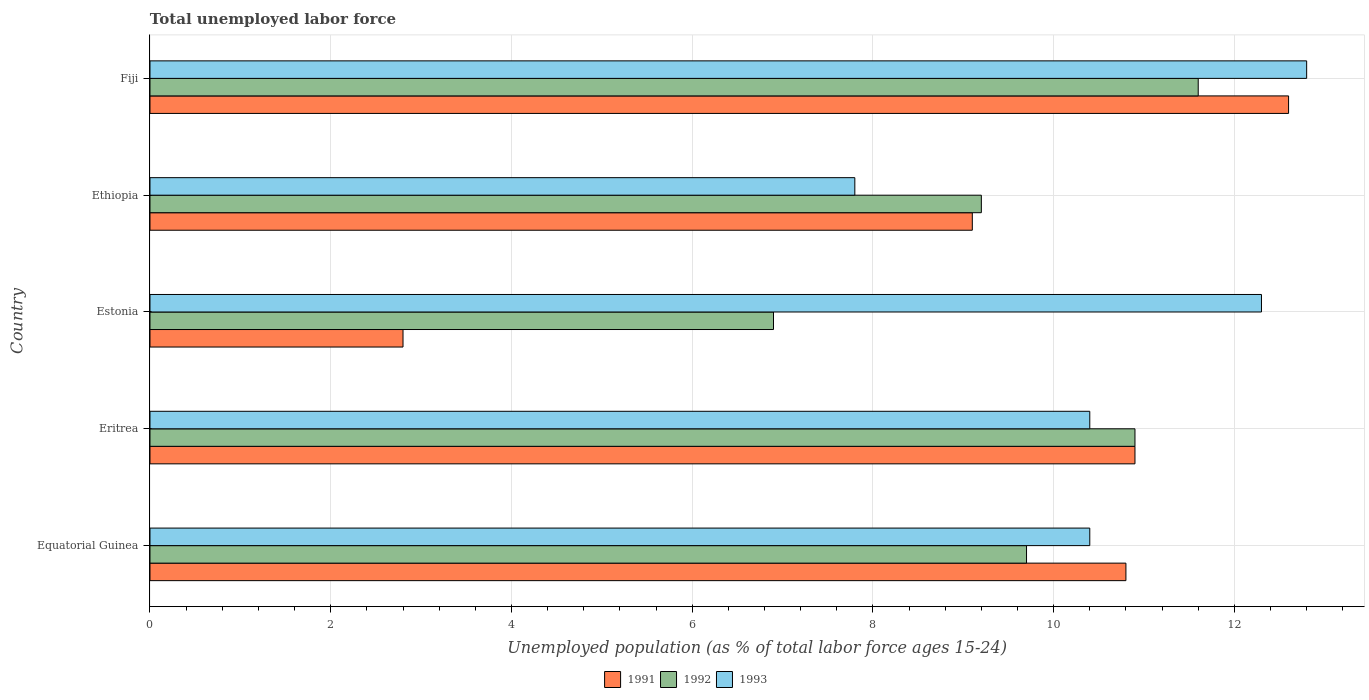How many different coloured bars are there?
Ensure brevity in your answer.  3. How many groups of bars are there?
Your answer should be compact. 5. Are the number of bars on each tick of the Y-axis equal?
Make the answer very short. Yes. How many bars are there on the 5th tick from the top?
Provide a succinct answer. 3. What is the label of the 5th group of bars from the top?
Give a very brief answer. Equatorial Guinea. In how many cases, is the number of bars for a given country not equal to the number of legend labels?
Keep it short and to the point. 0. What is the percentage of unemployed population in in 1992 in Eritrea?
Provide a short and direct response. 10.9. Across all countries, what is the maximum percentage of unemployed population in in 1993?
Your answer should be very brief. 12.8. Across all countries, what is the minimum percentage of unemployed population in in 1993?
Give a very brief answer. 7.8. In which country was the percentage of unemployed population in in 1992 maximum?
Ensure brevity in your answer.  Fiji. In which country was the percentage of unemployed population in in 1992 minimum?
Your response must be concise. Estonia. What is the total percentage of unemployed population in in 1992 in the graph?
Offer a very short reply. 48.3. What is the difference between the percentage of unemployed population in in 1991 in Eritrea and that in Estonia?
Make the answer very short. 8.1. What is the difference between the percentage of unemployed population in in 1991 in Equatorial Guinea and the percentage of unemployed population in in 1992 in Estonia?
Offer a terse response. 3.9. What is the average percentage of unemployed population in in 1991 per country?
Offer a very short reply. 9.24. What is the difference between the percentage of unemployed population in in 1991 and percentage of unemployed population in in 1993 in Estonia?
Your answer should be very brief. -9.5. What is the ratio of the percentage of unemployed population in in 1992 in Ethiopia to that in Fiji?
Your response must be concise. 0.79. What is the difference between the highest and the second highest percentage of unemployed population in in 1992?
Your answer should be very brief. 0.7. What is the difference between the highest and the lowest percentage of unemployed population in in 1991?
Ensure brevity in your answer.  9.8. In how many countries, is the percentage of unemployed population in in 1991 greater than the average percentage of unemployed population in in 1991 taken over all countries?
Keep it short and to the point. 3. Is the sum of the percentage of unemployed population in in 1993 in Equatorial Guinea and Ethiopia greater than the maximum percentage of unemployed population in in 1991 across all countries?
Provide a short and direct response. Yes. How many bars are there?
Ensure brevity in your answer.  15. What is the difference between two consecutive major ticks on the X-axis?
Make the answer very short. 2. Are the values on the major ticks of X-axis written in scientific E-notation?
Make the answer very short. No. Does the graph contain any zero values?
Your answer should be compact. No. Does the graph contain grids?
Offer a very short reply. Yes. How many legend labels are there?
Your answer should be very brief. 3. What is the title of the graph?
Make the answer very short. Total unemployed labor force. Does "1964" appear as one of the legend labels in the graph?
Your answer should be very brief. No. What is the label or title of the X-axis?
Offer a terse response. Unemployed population (as % of total labor force ages 15-24). What is the label or title of the Y-axis?
Your answer should be very brief. Country. What is the Unemployed population (as % of total labor force ages 15-24) of 1991 in Equatorial Guinea?
Make the answer very short. 10.8. What is the Unemployed population (as % of total labor force ages 15-24) of 1992 in Equatorial Guinea?
Your answer should be compact. 9.7. What is the Unemployed population (as % of total labor force ages 15-24) in 1993 in Equatorial Guinea?
Offer a terse response. 10.4. What is the Unemployed population (as % of total labor force ages 15-24) of 1991 in Eritrea?
Your response must be concise. 10.9. What is the Unemployed population (as % of total labor force ages 15-24) of 1992 in Eritrea?
Make the answer very short. 10.9. What is the Unemployed population (as % of total labor force ages 15-24) in 1993 in Eritrea?
Your answer should be very brief. 10.4. What is the Unemployed population (as % of total labor force ages 15-24) of 1991 in Estonia?
Provide a short and direct response. 2.8. What is the Unemployed population (as % of total labor force ages 15-24) of 1992 in Estonia?
Provide a short and direct response. 6.9. What is the Unemployed population (as % of total labor force ages 15-24) of 1993 in Estonia?
Your answer should be very brief. 12.3. What is the Unemployed population (as % of total labor force ages 15-24) in 1991 in Ethiopia?
Offer a very short reply. 9.1. What is the Unemployed population (as % of total labor force ages 15-24) of 1992 in Ethiopia?
Ensure brevity in your answer.  9.2. What is the Unemployed population (as % of total labor force ages 15-24) in 1993 in Ethiopia?
Provide a succinct answer. 7.8. What is the Unemployed population (as % of total labor force ages 15-24) in 1991 in Fiji?
Ensure brevity in your answer.  12.6. What is the Unemployed population (as % of total labor force ages 15-24) in 1992 in Fiji?
Ensure brevity in your answer.  11.6. What is the Unemployed population (as % of total labor force ages 15-24) of 1993 in Fiji?
Your answer should be compact. 12.8. Across all countries, what is the maximum Unemployed population (as % of total labor force ages 15-24) of 1991?
Your response must be concise. 12.6. Across all countries, what is the maximum Unemployed population (as % of total labor force ages 15-24) in 1992?
Give a very brief answer. 11.6. Across all countries, what is the maximum Unemployed population (as % of total labor force ages 15-24) in 1993?
Your response must be concise. 12.8. Across all countries, what is the minimum Unemployed population (as % of total labor force ages 15-24) of 1991?
Offer a very short reply. 2.8. Across all countries, what is the minimum Unemployed population (as % of total labor force ages 15-24) of 1992?
Your answer should be compact. 6.9. Across all countries, what is the minimum Unemployed population (as % of total labor force ages 15-24) of 1993?
Your response must be concise. 7.8. What is the total Unemployed population (as % of total labor force ages 15-24) in 1991 in the graph?
Provide a succinct answer. 46.2. What is the total Unemployed population (as % of total labor force ages 15-24) in 1992 in the graph?
Give a very brief answer. 48.3. What is the total Unemployed population (as % of total labor force ages 15-24) in 1993 in the graph?
Your response must be concise. 53.7. What is the difference between the Unemployed population (as % of total labor force ages 15-24) in 1991 in Equatorial Guinea and that in Eritrea?
Provide a short and direct response. -0.1. What is the difference between the Unemployed population (as % of total labor force ages 15-24) of 1992 in Equatorial Guinea and that in Eritrea?
Keep it short and to the point. -1.2. What is the difference between the Unemployed population (as % of total labor force ages 15-24) in 1993 in Equatorial Guinea and that in Eritrea?
Provide a succinct answer. 0. What is the difference between the Unemployed population (as % of total labor force ages 15-24) of 1991 in Equatorial Guinea and that in Estonia?
Give a very brief answer. 8. What is the difference between the Unemployed population (as % of total labor force ages 15-24) of 1993 in Equatorial Guinea and that in Estonia?
Offer a very short reply. -1.9. What is the difference between the Unemployed population (as % of total labor force ages 15-24) in 1992 in Equatorial Guinea and that in Ethiopia?
Ensure brevity in your answer.  0.5. What is the difference between the Unemployed population (as % of total labor force ages 15-24) in 1991 in Equatorial Guinea and that in Fiji?
Make the answer very short. -1.8. What is the difference between the Unemployed population (as % of total labor force ages 15-24) of 1993 in Eritrea and that in Estonia?
Ensure brevity in your answer.  -1.9. What is the difference between the Unemployed population (as % of total labor force ages 15-24) in 1992 in Eritrea and that in Fiji?
Your answer should be very brief. -0.7. What is the difference between the Unemployed population (as % of total labor force ages 15-24) in 1993 in Eritrea and that in Fiji?
Offer a very short reply. -2.4. What is the difference between the Unemployed population (as % of total labor force ages 15-24) in 1992 in Estonia and that in Ethiopia?
Make the answer very short. -2.3. What is the difference between the Unemployed population (as % of total labor force ages 15-24) in 1993 in Estonia and that in Ethiopia?
Make the answer very short. 4.5. What is the difference between the Unemployed population (as % of total labor force ages 15-24) in 1993 in Estonia and that in Fiji?
Ensure brevity in your answer.  -0.5. What is the difference between the Unemployed population (as % of total labor force ages 15-24) in 1991 in Ethiopia and that in Fiji?
Offer a terse response. -3.5. What is the difference between the Unemployed population (as % of total labor force ages 15-24) of 1993 in Ethiopia and that in Fiji?
Provide a succinct answer. -5. What is the difference between the Unemployed population (as % of total labor force ages 15-24) of 1992 in Equatorial Guinea and the Unemployed population (as % of total labor force ages 15-24) of 1993 in Eritrea?
Your answer should be very brief. -0.7. What is the difference between the Unemployed population (as % of total labor force ages 15-24) in 1992 in Equatorial Guinea and the Unemployed population (as % of total labor force ages 15-24) in 1993 in Estonia?
Ensure brevity in your answer.  -2.6. What is the difference between the Unemployed population (as % of total labor force ages 15-24) of 1991 in Equatorial Guinea and the Unemployed population (as % of total labor force ages 15-24) of 1992 in Fiji?
Offer a very short reply. -0.8. What is the difference between the Unemployed population (as % of total labor force ages 15-24) in 1991 in Equatorial Guinea and the Unemployed population (as % of total labor force ages 15-24) in 1993 in Fiji?
Your response must be concise. -2. What is the difference between the Unemployed population (as % of total labor force ages 15-24) in 1992 in Equatorial Guinea and the Unemployed population (as % of total labor force ages 15-24) in 1993 in Fiji?
Your answer should be compact. -3.1. What is the difference between the Unemployed population (as % of total labor force ages 15-24) of 1991 in Eritrea and the Unemployed population (as % of total labor force ages 15-24) of 1993 in Estonia?
Provide a short and direct response. -1.4. What is the difference between the Unemployed population (as % of total labor force ages 15-24) in 1992 in Eritrea and the Unemployed population (as % of total labor force ages 15-24) in 1993 in Estonia?
Make the answer very short. -1.4. What is the difference between the Unemployed population (as % of total labor force ages 15-24) in 1991 in Eritrea and the Unemployed population (as % of total labor force ages 15-24) in 1993 in Ethiopia?
Your answer should be very brief. 3.1. What is the difference between the Unemployed population (as % of total labor force ages 15-24) of 1992 in Eritrea and the Unemployed population (as % of total labor force ages 15-24) of 1993 in Ethiopia?
Offer a terse response. 3.1. What is the difference between the Unemployed population (as % of total labor force ages 15-24) of 1991 in Eritrea and the Unemployed population (as % of total labor force ages 15-24) of 1992 in Fiji?
Make the answer very short. -0.7. What is the difference between the Unemployed population (as % of total labor force ages 15-24) of 1991 in Estonia and the Unemployed population (as % of total labor force ages 15-24) of 1992 in Ethiopia?
Offer a terse response. -6.4. What is the difference between the Unemployed population (as % of total labor force ages 15-24) in 1992 in Estonia and the Unemployed population (as % of total labor force ages 15-24) in 1993 in Ethiopia?
Your response must be concise. -0.9. What is the difference between the Unemployed population (as % of total labor force ages 15-24) in 1991 in Estonia and the Unemployed population (as % of total labor force ages 15-24) in 1992 in Fiji?
Your response must be concise. -8.8. What is the difference between the Unemployed population (as % of total labor force ages 15-24) in 1991 in Ethiopia and the Unemployed population (as % of total labor force ages 15-24) in 1992 in Fiji?
Ensure brevity in your answer.  -2.5. What is the difference between the Unemployed population (as % of total labor force ages 15-24) of 1992 in Ethiopia and the Unemployed population (as % of total labor force ages 15-24) of 1993 in Fiji?
Your answer should be compact. -3.6. What is the average Unemployed population (as % of total labor force ages 15-24) in 1991 per country?
Ensure brevity in your answer.  9.24. What is the average Unemployed population (as % of total labor force ages 15-24) in 1992 per country?
Keep it short and to the point. 9.66. What is the average Unemployed population (as % of total labor force ages 15-24) of 1993 per country?
Keep it short and to the point. 10.74. What is the difference between the Unemployed population (as % of total labor force ages 15-24) in 1991 and Unemployed population (as % of total labor force ages 15-24) in 1992 in Equatorial Guinea?
Provide a short and direct response. 1.1. What is the difference between the Unemployed population (as % of total labor force ages 15-24) in 1992 and Unemployed population (as % of total labor force ages 15-24) in 1993 in Equatorial Guinea?
Your answer should be very brief. -0.7. What is the difference between the Unemployed population (as % of total labor force ages 15-24) in 1992 and Unemployed population (as % of total labor force ages 15-24) in 1993 in Eritrea?
Ensure brevity in your answer.  0.5. What is the difference between the Unemployed population (as % of total labor force ages 15-24) in 1991 and Unemployed population (as % of total labor force ages 15-24) in 1992 in Estonia?
Offer a very short reply. -4.1. What is the difference between the Unemployed population (as % of total labor force ages 15-24) in 1991 and Unemployed population (as % of total labor force ages 15-24) in 1993 in Estonia?
Your response must be concise. -9.5. What is the difference between the Unemployed population (as % of total labor force ages 15-24) of 1991 and Unemployed population (as % of total labor force ages 15-24) of 1992 in Ethiopia?
Keep it short and to the point. -0.1. What is the difference between the Unemployed population (as % of total labor force ages 15-24) in 1991 and Unemployed population (as % of total labor force ages 15-24) in 1993 in Fiji?
Your response must be concise. -0.2. What is the difference between the Unemployed population (as % of total labor force ages 15-24) in 1992 and Unemployed population (as % of total labor force ages 15-24) in 1993 in Fiji?
Ensure brevity in your answer.  -1.2. What is the ratio of the Unemployed population (as % of total labor force ages 15-24) of 1992 in Equatorial Guinea to that in Eritrea?
Provide a short and direct response. 0.89. What is the ratio of the Unemployed population (as % of total labor force ages 15-24) in 1991 in Equatorial Guinea to that in Estonia?
Give a very brief answer. 3.86. What is the ratio of the Unemployed population (as % of total labor force ages 15-24) in 1992 in Equatorial Guinea to that in Estonia?
Offer a terse response. 1.41. What is the ratio of the Unemployed population (as % of total labor force ages 15-24) of 1993 in Equatorial Guinea to that in Estonia?
Offer a very short reply. 0.85. What is the ratio of the Unemployed population (as % of total labor force ages 15-24) in 1991 in Equatorial Guinea to that in Ethiopia?
Give a very brief answer. 1.19. What is the ratio of the Unemployed population (as % of total labor force ages 15-24) in 1992 in Equatorial Guinea to that in Ethiopia?
Provide a short and direct response. 1.05. What is the ratio of the Unemployed population (as % of total labor force ages 15-24) of 1993 in Equatorial Guinea to that in Ethiopia?
Give a very brief answer. 1.33. What is the ratio of the Unemployed population (as % of total labor force ages 15-24) in 1991 in Equatorial Guinea to that in Fiji?
Offer a terse response. 0.86. What is the ratio of the Unemployed population (as % of total labor force ages 15-24) of 1992 in Equatorial Guinea to that in Fiji?
Ensure brevity in your answer.  0.84. What is the ratio of the Unemployed population (as % of total labor force ages 15-24) of 1993 in Equatorial Guinea to that in Fiji?
Make the answer very short. 0.81. What is the ratio of the Unemployed population (as % of total labor force ages 15-24) in 1991 in Eritrea to that in Estonia?
Provide a succinct answer. 3.89. What is the ratio of the Unemployed population (as % of total labor force ages 15-24) in 1992 in Eritrea to that in Estonia?
Provide a short and direct response. 1.58. What is the ratio of the Unemployed population (as % of total labor force ages 15-24) of 1993 in Eritrea to that in Estonia?
Provide a short and direct response. 0.85. What is the ratio of the Unemployed population (as % of total labor force ages 15-24) of 1991 in Eritrea to that in Ethiopia?
Your answer should be very brief. 1.2. What is the ratio of the Unemployed population (as % of total labor force ages 15-24) in 1992 in Eritrea to that in Ethiopia?
Provide a succinct answer. 1.18. What is the ratio of the Unemployed population (as % of total labor force ages 15-24) of 1993 in Eritrea to that in Ethiopia?
Provide a succinct answer. 1.33. What is the ratio of the Unemployed population (as % of total labor force ages 15-24) of 1991 in Eritrea to that in Fiji?
Your answer should be compact. 0.87. What is the ratio of the Unemployed population (as % of total labor force ages 15-24) in 1992 in Eritrea to that in Fiji?
Offer a very short reply. 0.94. What is the ratio of the Unemployed population (as % of total labor force ages 15-24) of 1993 in Eritrea to that in Fiji?
Offer a very short reply. 0.81. What is the ratio of the Unemployed population (as % of total labor force ages 15-24) of 1991 in Estonia to that in Ethiopia?
Your answer should be very brief. 0.31. What is the ratio of the Unemployed population (as % of total labor force ages 15-24) of 1992 in Estonia to that in Ethiopia?
Make the answer very short. 0.75. What is the ratio of the Unemployed population (as % of total labor force ages 15-24) in 1993 in Estonia to that in Ethiopia?
Offer a terse response. 1.58. What is the ratio of the Unemployed population (as % of total labor force ages 15-24) of 1991 in Estonia to that in Fiji?
Offer a very short reply. 0.22. What is the ratio of the Unemployed population (as % of total labor force ages 15-24) in 1992 in Estonia to that in Fiji?
Your answer should be compact. 0.59. What is the ratio of the Unemployed population (as % of total labor force ages 15-24) in 1993 in Estonia to that in Fiji?
Offer a terse response. 0.96. What is the ratio of the Unemployed population (as % of total labor force ages 15-24) of 1991 in Ethiopia to that in Fiji?
Provide a succinct answer. 0.72. What is the ratio of the Unemployed population (as % of total labor force ages 15-24) of 1992 in Ethiopia to that in Fiji?
Your response must be concise. 0.79. What is the ratio of the Unemployed population (as % of total labor force ages 15-24) in 1993 in Ethiopia to that in Fiji?
Your answer should be very brief. 0.61. What is the difference between the highest and the second highest Unemployed population (as % of total labor force ages 15-24) in 1991?
Provide a succinct answer. 1.7. What is the difference between the highest and the second highest Unemployed population (as % of total labor force ages 15-24) of 1992?
Ensure brevity in your answer.  0.7. What is the difference between the highest and the lowest Unemployed population (as % of total labor force ages 15-24) of 1992?
Provide a short and direct response. 4.7. 